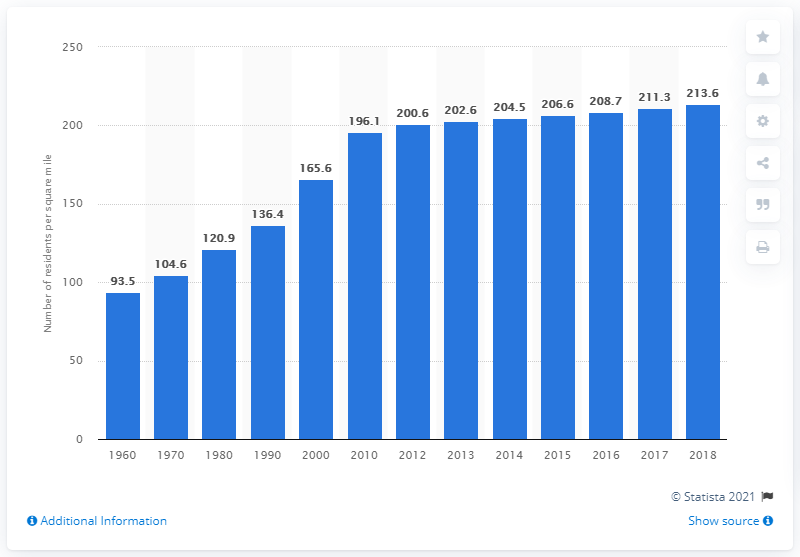Specify some key components in this picture. The population density of North Carolina in 2018 was 213.6 people per square mile. 